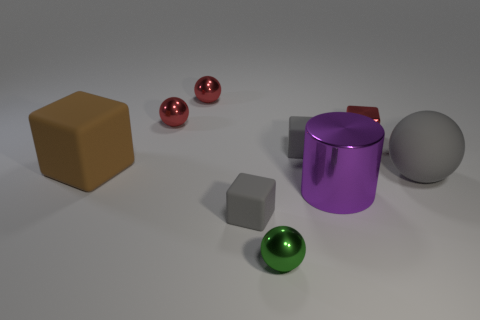What objects are in the foreground of the image? In the foreground of the image, there's a green sphere to the right and a smaller, grey cube towards the center. 